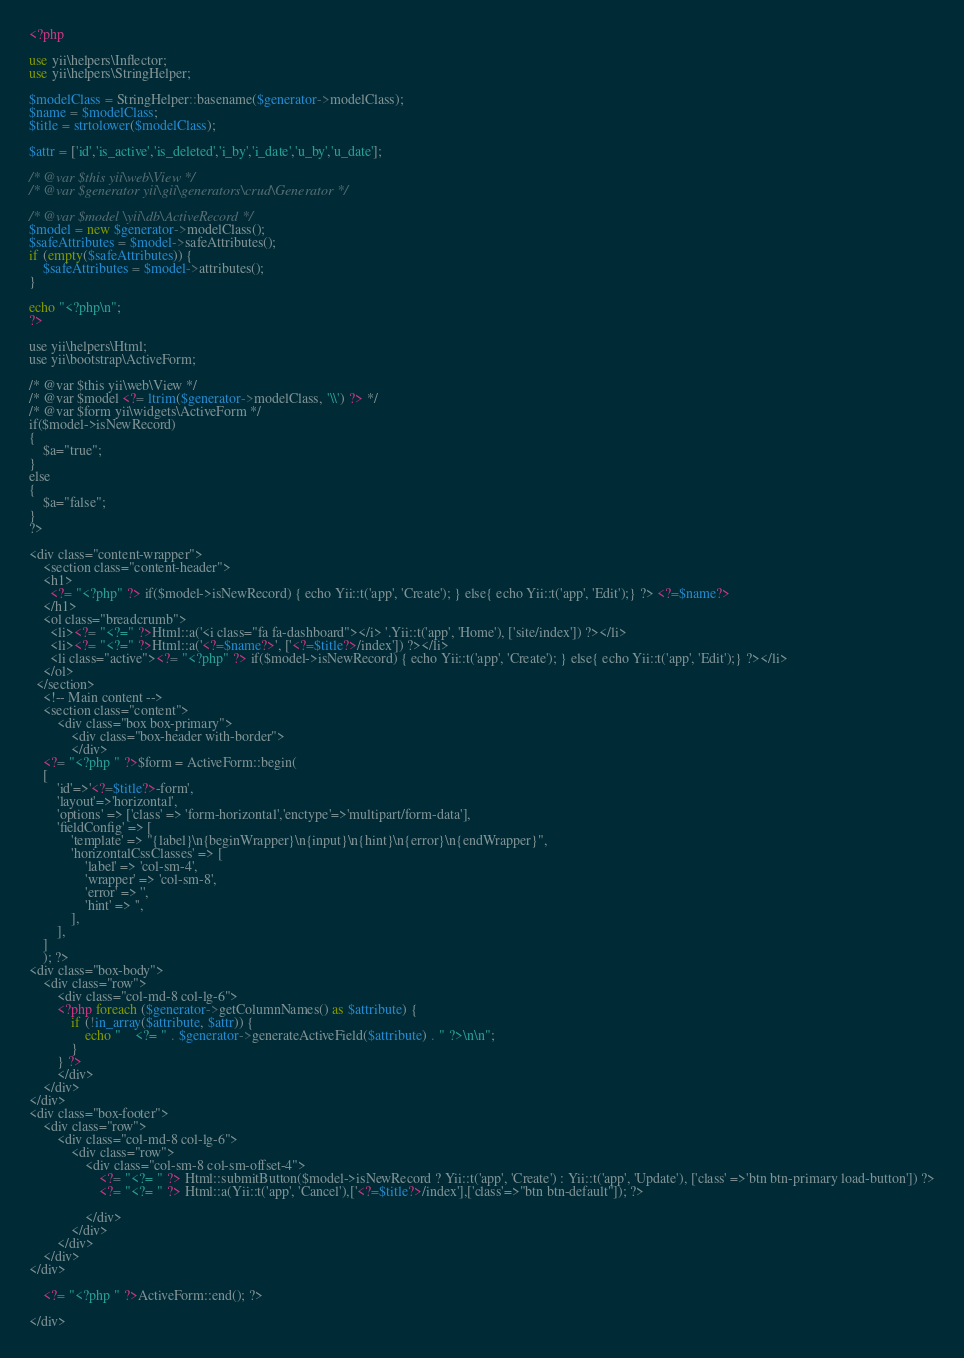<code> <loc_0><loc_0><loc_500><loc_500><_PHP_><?php

use yii\helpers\Inflector;
use yii\helpers\StringHelper;

$modelClass = StringHelper::basename($generator->modelClass);
$name = $modelClass;
$title = strtolower($modelClass);

$attr = ['id','is_active','is_deleted','i_by','i_date','u_by','u_date'];

/* @var $this yii\web\View */
/* @var $generator yii\gii\generators\crud\Generator */

/* @var $model \yii\db\ActiveRecord */
$model = new $generator->modelClass();
$safeAttributes = $model->safeAttributes();
if (empty($safeAttributes)) {
    $safeAttributes = $model->attributes();
}

echo "<?php\n";
?>

use yii\helpers\Html;
use yii\bootstrap\ActiveForm;

/* @var $this yii\web\View */
/* @var $model <?= ltrim($generator->modelClass, '\\') ?> */
/* @var $form yii\widgets\ActiveForm */
if($model->isNewRecord)
{
    $a="true";
}
else
{
    $a="false";
}
?>

<div class="content-wrapper">
    <section class="content-header">
    <h1>
      <?= "<?php" ?> if($model->isNewRecord) { echo Yii::t('app', 'Create'); } else{ echo Yii::t('app', 'Edit');} ?> <?=$name?>
    </h1>
    <ol class="breadcrumb">
      <li><?= "<?=" ?>Html::a('<i class="fa fa-dashboard"></i> '.Yii::t('app', 'Home'), ['site/index']) ?></li>
      <li><?= "<?=" ?>Html::a('<?=$name?>', ['<?=$title?>/index']) ?></li>
      <li class="active"><?= "<?php" ?> if($model->isNewRecord) { echo Yii::t('app', 'Create'); } else{ echo Yii::t('app', 'Edit');} ?></li>
    </ol>
  </section>
    <!-- Main content -->
	<section class="content">
        <div class="box box-primary">
            <div class="box-header with-border">
            </div>
    <?= "<?php " ?>$form = ActiveForm::begin(
    [
        'id'=>'<?=$title?>-form',
        'layout'=>'horizontal',
        'options' => ['class' => 'form-horizontal','enctype'=>'multipart/form-data'],
        'fieldConfig' => [
            'template' => "{label}\n{beginWrapper}\n{input}\n{hint}\n{error}\n{endWrapper}",
            'horizontalCssClasses' => [
                'label' => 'col-sm-4',
                'wrapper' => 'col-sm-8',
                'error' => '',
                'hint' => '',
            ],
        ],
    ]
    ); ?>
<div class="box-body">
    <div class="row">
        <div class="col-md-8 col-lg-6">
        <?php foreach ($generator->getColumnNames() as $attribute) {
            if (!in_array($attribute, $attr)) {
                echo "    <?= " . $generator->generateActiveField($attribute) . " ?>\n\n";
            }
        } ?>
        </div>
    </div>
</div>
<div class="box-footer">
    <div class="row">
        <div class="col-md-8 col-lg-6">
            <div class="row">
                <div class="col-sm-8 col-sm-offset-4">
                    <?= "<?= " ?> Html::submitButton($model->isNewRecord ? Yii::t('app', 'Create') : Yii::t('app', 'Update'), ['class' =>'btn btn-primary load-button']) ?>
					<?= "<?= " ?> Html::a(Yii::t('app', 'Cancel'),['<?=$title?>/index'],['class'=>"btn btn-default"]); ?>

                </div>
            </div>
        </div>
    </div>
</div>

    <?= "<?php " ?>ActiveForm::end(); ?>

</div>
</code> 